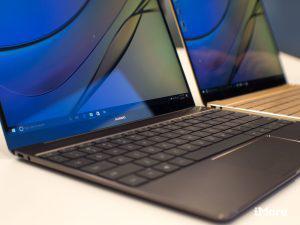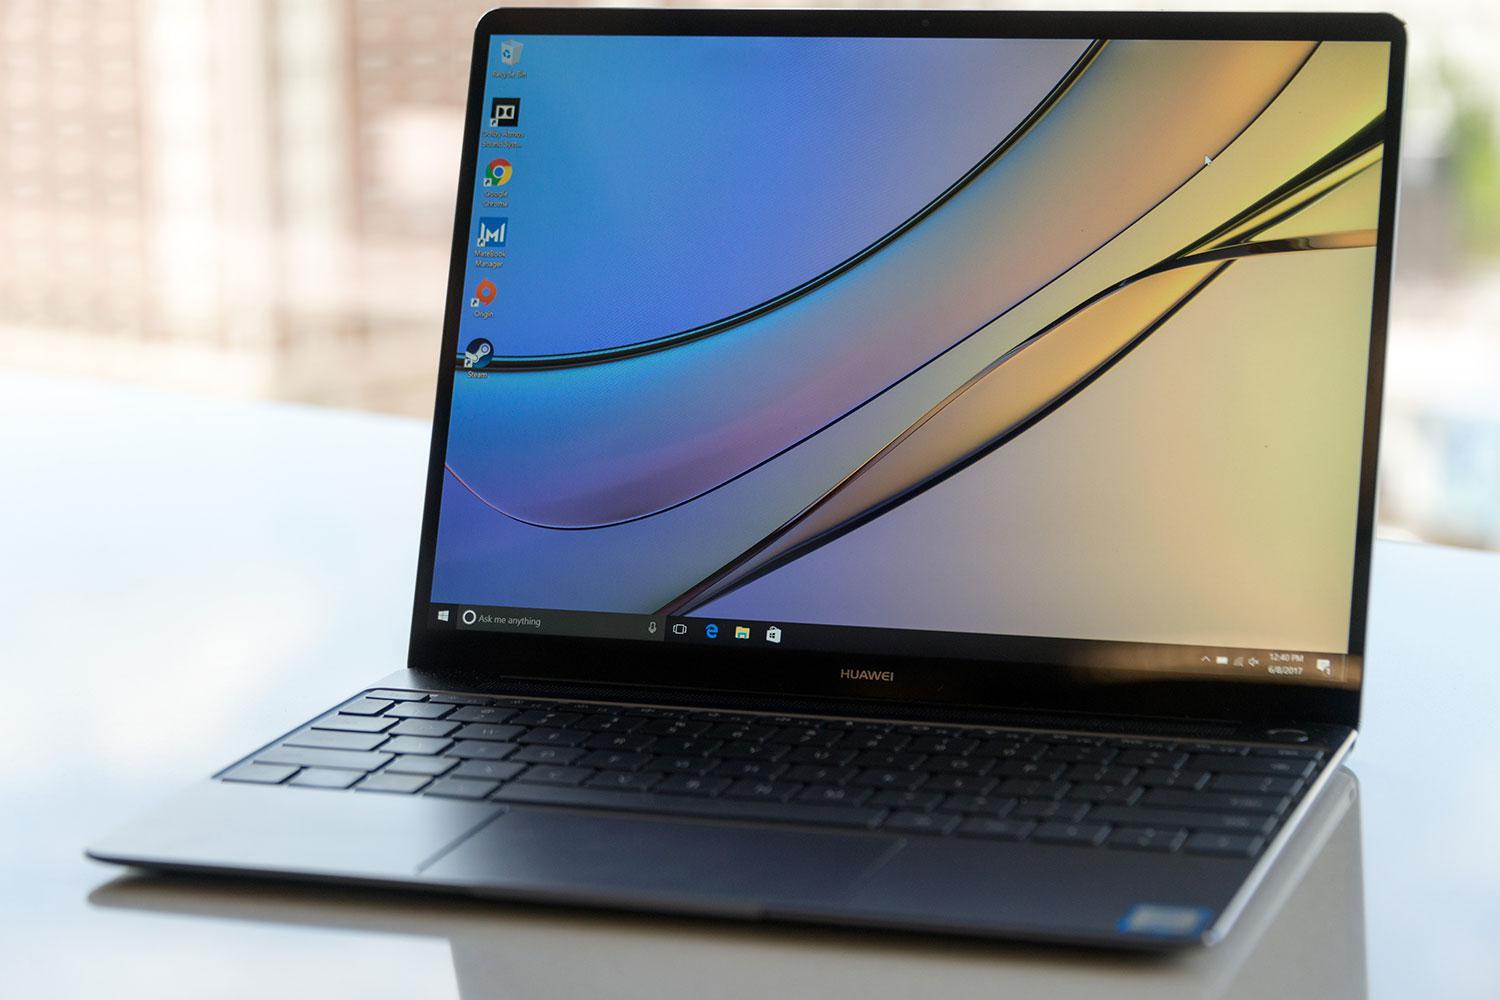The first image is the image on the left, the second image is the image on the right. Given the left and right images, does the statement "One image shows side-by-side open laptops and the other shows a single open laptop, and all laptops are angled somewhat leftward and display curving lines on the screen." hold true? Answer yes or no. No. The first image is the image on the left, the second image is the image on the right. Examine the images to the left and right. Is the description "All the desktops have the same design." accurate? Answer yes or no. Yes. 